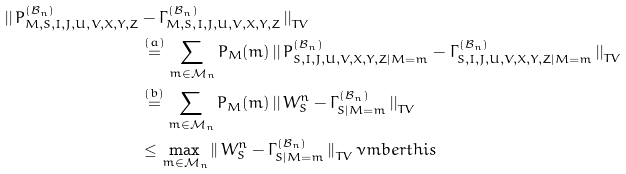Convert formula to latex. <formula><loc_0><loc_0><loc_500><loc_500>\left | \right | P ^ { ( \mathcal { B } _ { n } ) } _ { M , S , I , J , U , V , X , Y , Z } & - \Gamma ^ { ( \mathcal { B } _ { n } ) } _ { M , S , I , J , U , V , X , Y , Z } \left | \right | _ { T V } \\ & \stackrel { ( a ) } = \sum _ { m \in \mathcal { M } _ { n } } P _ { M } ( m ) \left | \right | P ^ { ( \mathcal { B } _ { n } ) } _ { S , I , J , U , V , X , Y , Z | M = m } - \Gamma ^ { ( \mathcal { B } _ { n } ) } _ { S , I , J , U , V , X , Y , Z | M = m } \left | \right | _ { T V } \\ & \stackrel { ( b ) } = \sum _ { m \in \mathcal { M } _ { n } } P _ { M } ( m ) \left | \right | W _ { S } ^ { n } - \Gamma ^ { ( \mathcal { B } _ { n } ) } _ { S | M = m } \left | \right | _ { T V } \\ & \leq \max _ { m \in \mathcal { M } _ { n } } \left | \right | W _ { S } ^ { n } - \Gamma ^ { ( \mathcal { B } _ { n } ) } _ { S | M = m } \left | \right | _ { T V } \nu m b e r t h i s</formula> 